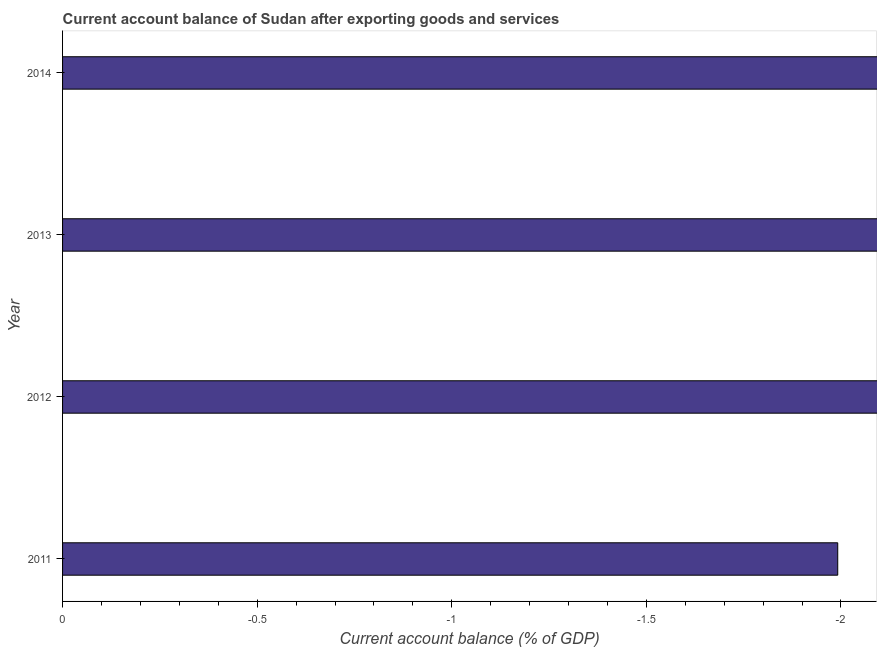Does the graph contain any zero values?
Offer a very short reply. Yes. What is the title of the graph?
Make the answer very short. Current account balance of Sudan after exporting goods and services. What is the label or title of the X-axis?
Give a very brief answer. Current account balance (% of GDP). What is the current account balance in 2014?
Provide a succinct answer. 0. What is the sum of the current account balance?
Your response must be concise. 0. What is the median current account balance?
Your answer should be very brief. 0. In how many years, is the current account balance greater than -0.1 %?
Make the answer very short. 0. In how many years, is the current account balance greater than the average current account balance taken over all years?
Keep it short and to the point. 0. How many bars are there?
Offer a very short reply. 0. Are all the bars in the graph horizontal?
Your response must be concise. Yes. How many years are there in the graph?
Ensure brevity in your answer.  4. Are the values on the major ticks of X-axis written in scientific E-notation?
Keep it short and to the point. No. What is the Current account balance (% of GDP) in 2012?
Provide a short and direct response. 0. What is the Current account balance (% of GDP) in 2013?
Give a very brief answer. 0. What is the Current account balance (% of GDP) of 2014?
Your answer should be very brief. 0. 